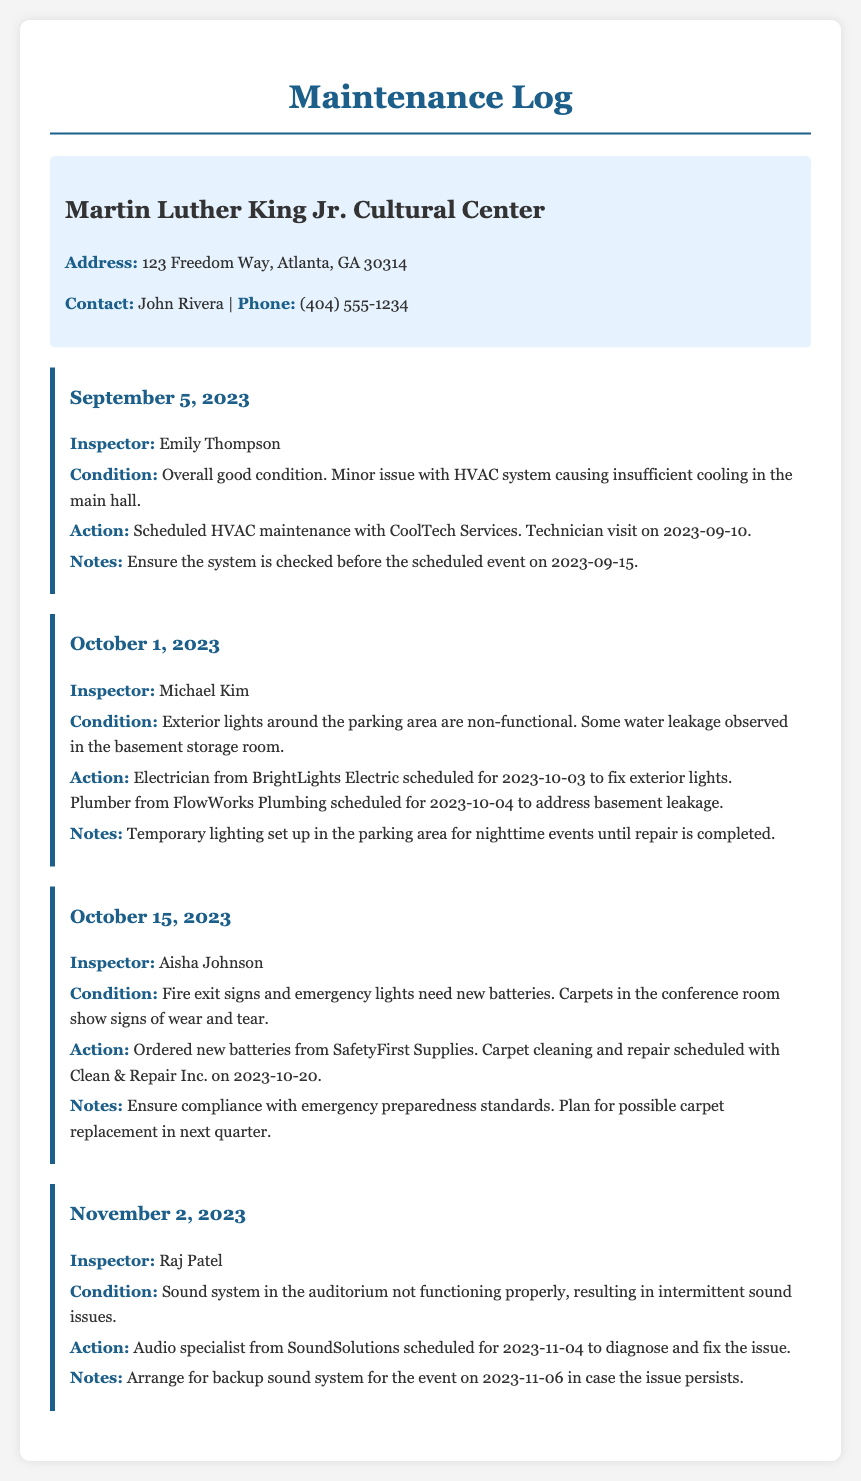what is the address of the venue? The address is specified in the venue information section of the document.
Answer: 123 Freedom Way, Atlanta, GA 30314 who is the contact person for the venue? The contact person is listed under the venue info in the document.
Answer: John Rivera what was the condition reported on September 5, 2023? The condition is described specifically in the entry for that date in the log.
Answer: Overall good condition when was the HVAC maintenance scheduled? The date for scheduled HVAC maintenance is captured in the action details on September 5, 2023.
Answer: 2023-09-10 what issue was observed on October 1, 2023? The issue is outlined in the condition description for that date.
Answer: Non-functional exterior lights how many different inspectors are mentioned in the log? The document provides entries with different inspectors mentioned, which can be counted.
Answer: Four what action was taken regarding the sound system on November 2, 2023? The action is specifically noted in the entry for that date related to sound system issues.
Answer: Scheduled for diagnosis and fix what is the scheduled date for carpet cleaning? This date is found in the action taken on October 15, 2023.
Answer: 2023-10-20 what is included in the notes for October 15, 2023? The notes section for that date provides important compliance information.
Answer: Ensure compliance with emergency preparedness standards 